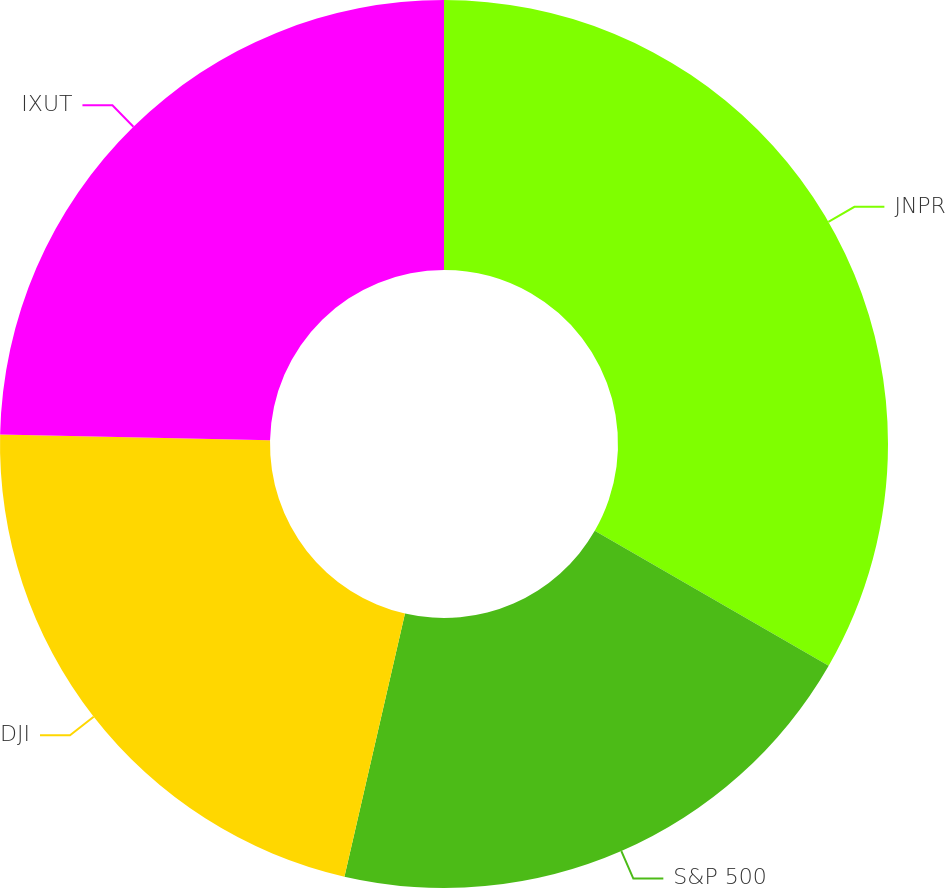Convert chart to OTSL. <chart><loc_0><loc_0><loc_500><loc_500><pie_chart><fcel>JNPR<fcel>S&P 500<fcel>DJI<fcel>IXUT<nl><fcel>33.32%<fcel>20.28%<fcel>21.74%<fcel>24.66%<nl></chart> 